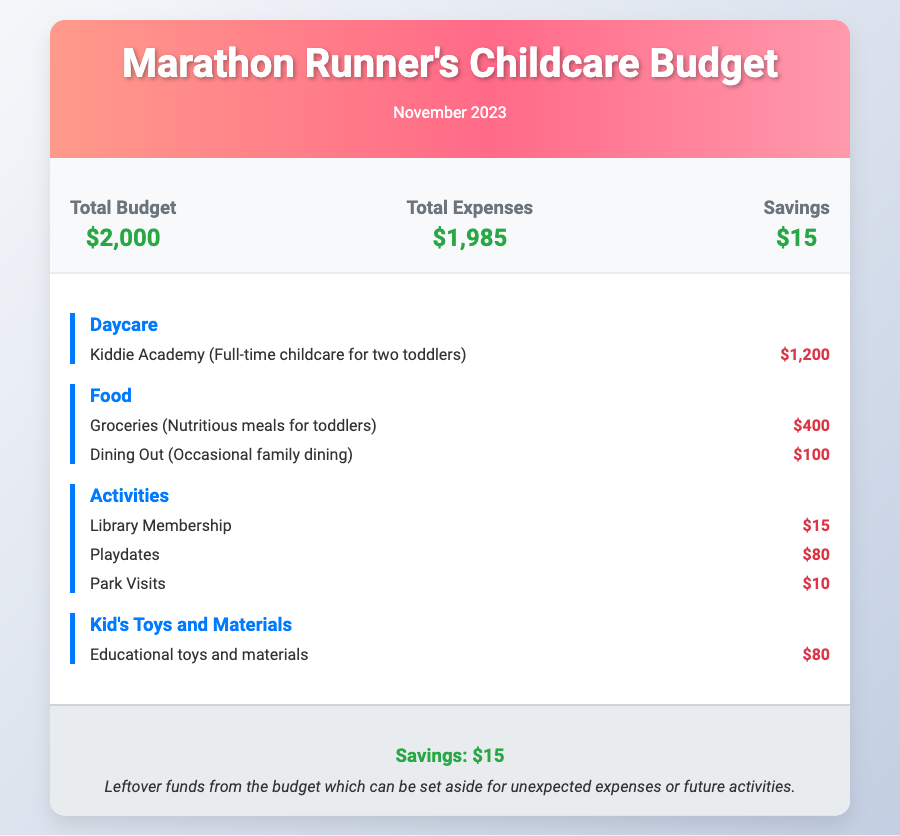What is the total budget? The total budget is stated clearly at the top of the document.
Answer: $2,000 How much is budgeted for daycare? The daycare expense is detailed under the daycare category in the expenses section.
Answer: $1,200 What is the total amount spent on activities? The total for activities can be calculated by adding up the expenses listed under the activities category.
Answer: $105 What is the savings amount? The savings amount is provided in the savings section of the document.
Answer: $15 How much is allocated for groceries? The groceries expense is listed under the food category in the expenses section.
Answer: $400 What is the cost of the library membership? The library membership fee is shown in the activities section of the expenses.
Answer: $15 How are the total expenses calculated? Total expenses are derived from the sum of all individual expense categories outlined in the document.
Answer: $1,985 What is the cost of educational toys and materials? The cost of educational toys is specified in the kid's toys and materials category.
Answer: $80 How much is set aside for unexpected expenses? The amount set aside is specified in the savings section.
Answer: $15 